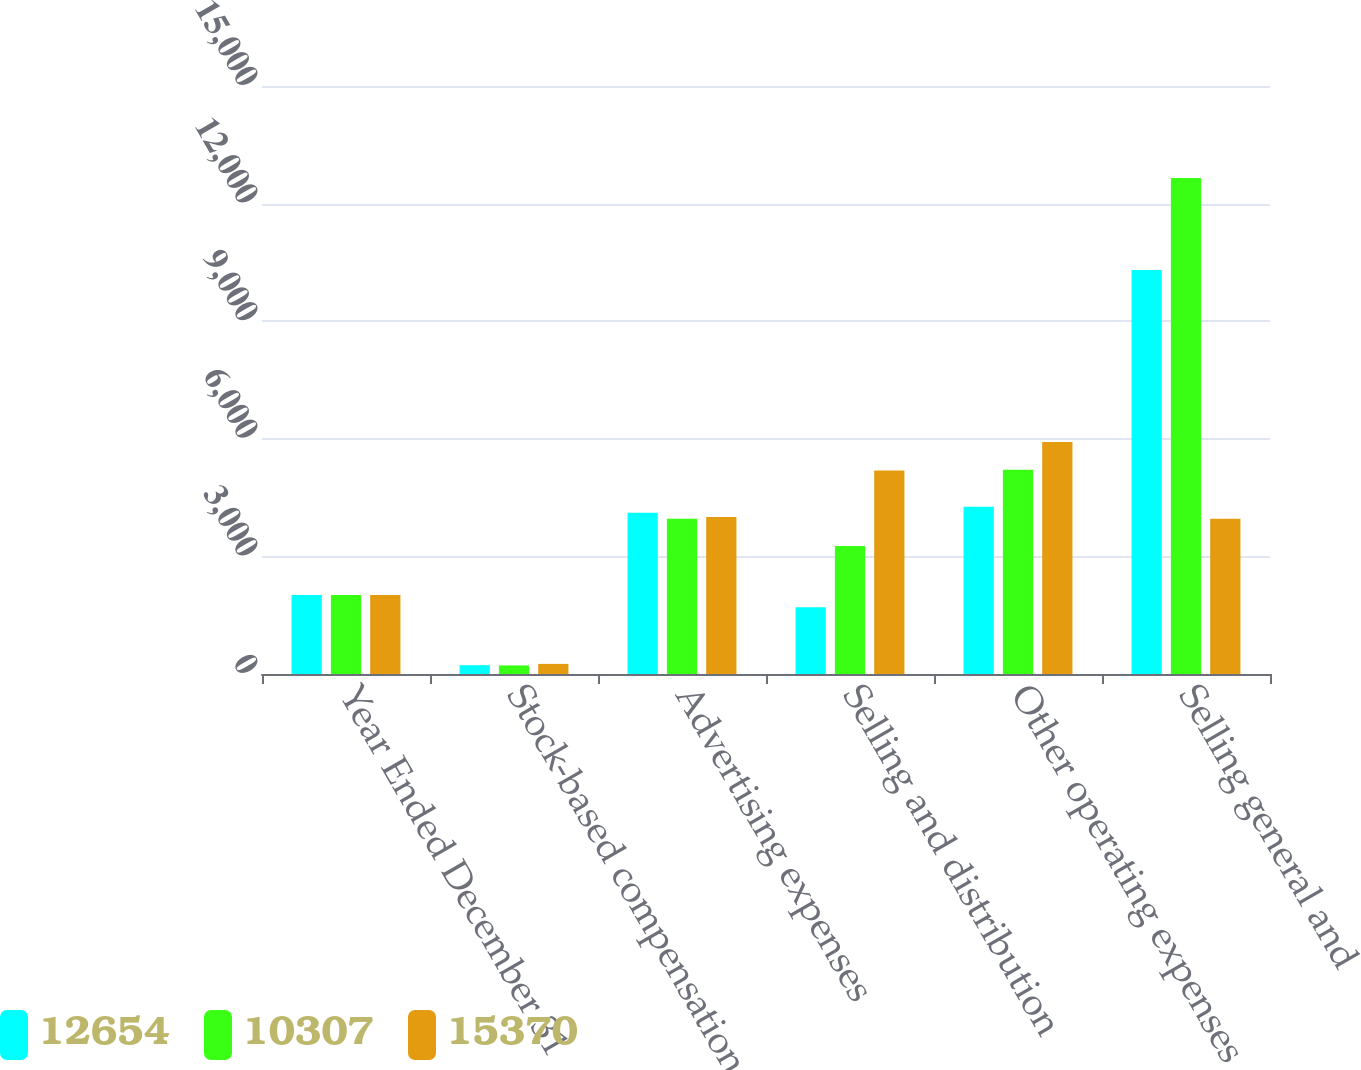<chart> <loc_0><loc_0><loc_500><loc_500><stacked_bar_chart><ecel><fcel>Year Ended December 31<fcel>Stock-based compensation<fcel>Advertising expenses<fcel>Selling and distribution<fcel>Other operating expenses<fcel>Selling general and<nl><fcel>12654<fcel>2018<fcel>225<fcel>4113<fcel>1701<fcel>4268<fcel>10307<nl><fcel>10307<fcel>2017<fcel>219<fcel>3958<fcel>3266<fcel>5211<fcel>12654<nl><fcel>15370<fcel>2016<fcel>258<fcel>4004<fcel>5189<fcel>5919<fcel>3958<nl></chart> 